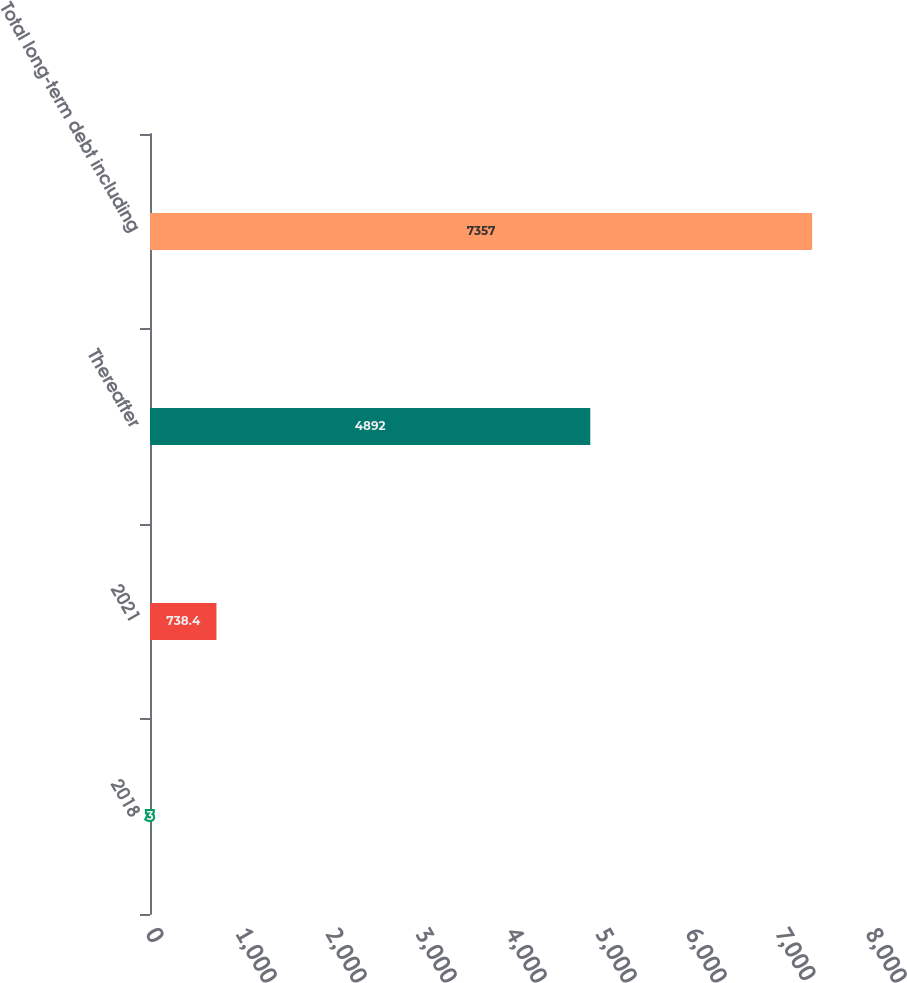Convert chart to OTSL. <chart><loc_0><loc_0><loc_500><loc_500><bar_chart><fcel>2018<fcel>2021<fcel>Thereafter<fcel>Total long-term debt including<nl><fcel>3<fcel>738.4<fcel>4892<fcel>7357<nl></chart> 